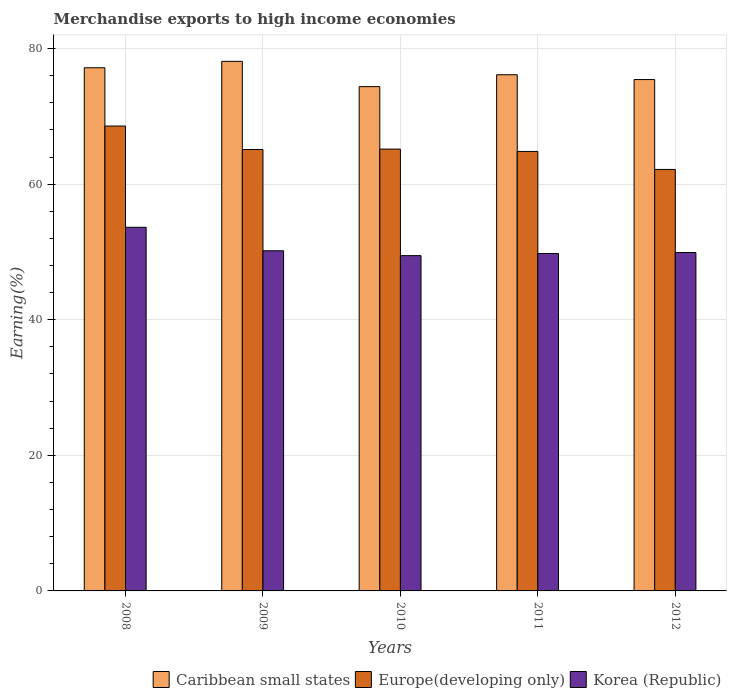How many different coloured bars are there?
Your response must be concise. 3. How many groups of bars are there?
Offer a terse response. 5. Are the number of bars on each tick of the X-axis equal?
Your answer should be compact. Yes. How many bars are there on the 3rd tick from the left?
Your response must be concise. 3. What is the percentage of amount earned from merchandise exports in Korea (Republic) in 2011?
Make the answer very short. 49.77. Across all years, what is the maximum percentage of amount earned from merchandise exports in Europe(developing only)?
Provide a succinct answer. 68.57. Across all years, what is the minimum percentage of amount earned from merchandise exports in Caribbean small states?
Your response must be concise. 74.38. In which year was the percentage of amount earned from merchandise exports in Europe(developing only) minimum?
Keep it short and to the point. 2012. What is the total percentage of amount earned from merchandise exports in Europe(developing only) in the graph?
Ensure brevity in your answer.  325.85. What is the difference between the percentage of amount earned from merchandise exports in Caribbean small states in 2009 and that in 2012?
Make the answer very short. 2.68. What is the difference between the percentage of amount earned from merchandise exports in Korea (Republic) in 2011 and the percentage of amount earned from merchandise exports in Caribbean small states in 2012?
Ensure brevity in your answer.  -25.66. What is the average percentage of amount earned from merchandise exports in Korea (Republic) per year?
Provide a short and direct response. 50.59. In the year 2012, what is the difference between the percentage of amount earned from merchandise exports in Caribbean small states and percentage of amount earned from merchandise exports in Europe(developing only)?
Provide a short and direct response. 13.26. What is the ratio of the percentage of amount earned from merchandise exports in Caribbean small states in 2009 to that in 2012?
Make the answer very short. 1.04. Is the difference between the percentage of amount earned from merchandise exports in Caribbean small states in 2010 and 2011 greater than the difference between the percentage of amount earned from merchandise exports in Europe(developing only) in 2010 and 2011?
Provide a short and direct response. No. What is the difference between the highest and the second highest percentage of amount earned from merchandise exports in Korea (Republic)?
Keep it short and to the point. 3.46. What is the difference between the highest and the lowest percentage of amount earned from merchandise exports in Korea (Republic)?
Your answer should be compact. 4.18. What does the 1st bar from the left in 2010 represents?
Your answer should be compact. Caribbean small states. How many bars are there?
Your answer should be very brief. 15. Are all the bars in the graph horizontal?
Your answer should be very brief. No. How many years are there in the graph?
Provide a succinct answer. 5. Does the graph contain any zero values?
Provide a short and direct response. No. Where does the legend appear in the graph?
Provide a short and direct response. Bottom right. How are the legend labels stacked?
Make the answer very short. Horizontal. What is the title of the graph?
Offer a very short reply. Merchandise exports to high income economies. Does "Ethiopia" appear as one of the legend labels in the graph?
Make the answer very short. No. What is the label or title of the X-axis?
Your response must be concise. Years. What is the label or title of the Y-axis?
Make the answer very short. Earning(%). What is the Earning(%) in Caribbean small states in 2008?
Keep it short and to the point. 77.17. What is the Earning(%) of Europe(developing only) in 2008?
Your response must be concise. 68.57. What is the Earning(%) of Korea (Republic) in 2008?
Keep it short and to the point. 53.64. What is the Earning(%) of Caribbean small states in 2009?
Offer a very short reply. 78.11. What is the Earning(%) of Europe(developing only) in 2009?
Provide a short and direct response. 65.11. What is the Earning(%) in Korea (Republic) in 2009?
Your response must be concise. 50.17. What is the Earning(%) of Caribbean small states in 2010?
Your response must be concise. 74.38. What is the Earning(%) of Europe(developing only) in 2010?
Ensure brevity in your answer.  65.17. What is the Earning(%) of Korea (Republic) in 2010?
Your response must be concise. 49.46. What is the Earning(%) of Caribbean small states in 2011?
Your answer should be very brief. 76.14. What is the Earning(%) in Europe(developing only) in 2011?
Offer a very short reply. 64.83. What is the Earning(%) of Korea (Republic) in 2011?
Make the answer very short. 49.77. What is the Earning(%) of Caribbean small states in 2012?
Your response must be concise. 75.43. What is the Earning(%) of Europe(developing only) in 2012?
Keep it short and to the point. 62.17. What is the Earning(%) of Korea (Republic) in 2012?
Make the answer very short. 49.92. Across all years, what is the maximum Earning(%) of Caribbean small states?
Your response must be concise. 78.11. Across all years, what is the maximum Earning(%) in Europe(developing only)?
Provide a short and direct response. 68.57. Across all years, what is the maximum Earning(%) of Korea (Republic)?
Offer a terse response. 53.64. Across all years, what is the minimum Earning(%) in Caribbean small states?
Offer a very short reply. 74.38. Across all years, what is the minimum Earning(%) of Europe(developing only)?
Your response must be concise. 62.17. Across all years, what is the minimum Earning(%) in Korea (Republic)?
Make the answer very short. 49.46. What is the total Earning(%) in Caribbean small states in the graph?
Ensure brevity in your answer.  381.23. What is the total Earning(%) of Europe(developing only) in the graph?
Your response must be concise. 325.85. What is the total Earning(%) in Korea (Republic) in the graph?
Your answer should be very brief. 252.95. What is the difference between the Earning(%) of Caribbean small states in 2008 and that in 2009?
Make the answer very short. -0.94. What is the difference between the Earning(%) in Europe(developing only) in 2008 and that in 2009?
Provide a succinct answer. 3.46. What is the difference between the Earning(%) of Korea (Republic) in 2008 and that in 2009?
Offer a terse response. 3.46. What is the difference between the Earning(%) in Caribbean small states in 2008 and that in 2010?
Ensure brevity in your answer.  2.78. What is the difference between the Earning(%) of Europe(developing only) in 2008 and that in 2010?
Keep it short and to the point. 3.4. What is the difference between the Earning(%) of Korea (Republic) in 2008 and that in 2010?
Your answer should be compact. 4.18. What is the difference between the Earning(%) of Europe(developing only) in 2008 and that in 2011?
Your answer should be very brief. 3.75. What is the difference between the Earning(%) in Korea (Republic) in 2008 and that in 2011?
Offer a terse response. 3.87. What is the difference between the Earning(%) in Caribbean small states in 2008 and that in 2012?
Ensure brevity in your answer.  1.74. What is the difference between the Earning(%) in Europe(developing only) in 2008 and that in 2012?
Offer a very short reply. 6.4. What is the difference between the Earning(%) in Korea (Republic) in 2008 and that in 2012?
Keep it short and to the point. 3.72. What is the difference between the Earning(%) of Caribbean small states in 2009 and that in 2010?
Provide a short and direct response. 3.73. What is the difference between the Earning(%) of Europe(developing only) in 2009 and that in 2010?
Offer a very short reply. -0.06. What is the difference between the Earning(%) of Korea (Republic) in 2009 and that in 2010?
Your answer should be compact. 0.72. What is the difference between the Earning(%) in Caribbean small states in 2009 and that in 2011?
Provide a short and direct response. 1.98. What is the difference between the Earning(%) in Europe(developing only) in 2009 and that in 2011?
Provide a succinct answer. 0.28. What is the difference between the Earning(%) in Korea (Republic) in 2009 and that in 2011?
Keep it short and to the point. 0.4. What is the difference between the Earning(%) of Caribbean small states in 2009 and that in 2012?
Your answer should be very brief. 2.68. What is the difference between the Earning(%) in Europe(developing only) in 2009 and that in 2012?
Give a very brief answer. 2.94. What is the difference between the Earning(%) in Korea (Republic) in 2009 and that in 2012?
Your response must be concise. 0.26. What is the difference between the Earning(%) of Caribbean small states in 2010 and that in 2011?
Provide a short and direct response. -1.75. What is the difference between the Earning(%) in Europe(developing only) in 2010 and that in 2011?
Your answer should be very brief. 0.34. What is the difference between the Earning(%) in Korea (Republic) in 2010 and that in 2011?
Provide a short and direct response. -0.31. What is the difference between the Earning(%) in Caribbean small states in 2010 and that in 2012?
Offer a terse response. -1.05. What is the difference between the Earning(%) of Europe(developing only) in 2010 and that in 2012?
Your answer should be very brief. 3. What is the difference between the Earning(%) in Korea (Republic) in 2010 and that in 2012?
Your answer should be very brief. -0.46. What is the difference between the Earning(%) of Caribbean small states in 2011 and that in 2012?
Make the answer very short. 0.71. What is the difference between the Earning(%) of Europe(developing only) in 2011 and that in 2012?
Offer a very short reply. 2.66. What is the difference between the Earning(%) in Korea (Republic) in 2011 and that in 2012?
Your answer should be compact. -0.15. What is the difference between the Earning(%) in Caribbean small states in 2008 and the Earning(%) in Europe(developing only) in 2009?
Offer a very short reply. 12.06. What is the difference between the Earning(%) in Caribbean small states in 2008 and the Earning(%) in Korea (Republic) in 2009?
Provide a succinct answer. 26.99. What is the difference between the Earning(%) in Europe(developing only) in 2008 and the Earning(%) in Korea (Republic) in 2009?
Provide a succinct answer. 18.4. What is the difference between the Earning(%) in Caribbean small states in 2008 and the Earning(%) in Europe(developing only) in 2010?
Offer a very short reply. 12. What is the difference between the Earning(%) in Caribbean small states in 2008 and the Earning(%) in Korea (Republic) in 2010?
Your answer should be compact. 27.71. What is the difference between the Earning(%) in Europe(developing only) in 2008 and the Earning(%) in Korea (Republic) in 2010?
Offer a very short reply. 19.12. What is the difference between the Earning(%) in Caribbean small states in 2008 and the Earning(%) in Europe(developing only) in 2011?
Provide a short and direct response. 12.34. What is the difference between the Earning(%) in Caribbean small states in 2008 and the Earning(%) in Korea (Republic) in 2011?
Your answer should be very brief. 27.4. What is the difference between the Earning(%) of Europe(developing only) in 2008 and the Earning(%) of Korea (Republic) in 2011?
Your answer should be very brief. 18.8. What is the difference between the Earning(%) in Caribbean small states in 2008 and the Earning(%) in Europe(developing only) in 2012?
Provide a succinct answer. 15. What is the difference between the Earning(%) of Caribbean small states in 2008 and the Earning(%) of Korea (Republic) in 2012?
Offer a very short reply. 27.25. What is the difference between the Earning(%) in Europe(developing only) in 2008 and the Earning(%) in Korea (Republic) in 2012?
Provide a succinct answer. 18.66. What is the difference between the Earning(%) of Caribbean small states in 2009 and the Earning(%) of Europe(developing only) in 2010?
Your response must be concise. 12.94. What is the difference between the Earning(%) in Caribbean small states in 2009 and the Earning(%) in Korea (Republic) in 2010?
Your answer should be very brief. 28.66. What is the difference between the Earning(%) of Europe(developing only) in 2009 and the Earning(%) of Korea (Republic) in 2010?
Give a very brief answer. 15.66. What is the difference between the Earning(%) of Caribbean small states in 2009 and the Earning(%) of Europe(developing only) in 2011?
Your response must be concise. 13.29. What is the difference between the Earning(%) in Caribbean small states in 2009 and the Earning(%) in Korea (Republic) in 2011?
Your response must be concise. 28.34. What is the difference between the Earning(%) of Europe(developing only) in 2009 and the Earning(%) of Korea (Republic) in 2011?
Offer a terse response. 15.34. What is the difference between the Earning(%) of Caribbean small states in 2009 and the Earning(%) of Europe(developing only) in 2012?
Your answer should be compact. 15.94. What is the difference between the Earning(%) in Caribbean small states in 2009 and the Earning(%) in Korea (Republic) in 2012?
Offer a terse response. 28.2. What is the difference between the Earning(%) in Europe(developing only) in 2009 and the Earning(%) in Korea (Republic) in 2012?
Provide a succinct answer. 15.19. What is the difference between the Earning(%) of Caribbean small states in 2010 and the Earning(%) of Europe(developing only) in 2011?
Provide a short and direct response. 9.56. What is the difference between the Earning(%) of Caribbean small states in 2010 and the Earning(%) of Korea (Republic) in 2011?
Your answer should be compact. 24.61. What is the difference between the Earning(%) in Europe(developing only) in 2010 and the Earning(%) in Korea (Republic) in 2011?
Keep it short and to the point. 15.4. What is the difference between the Earning(%) of Caribbean small states in 2010 and the Earning(%) of Europe(developing only) in 2012?
Make the answer very short. 12.21. What is the difference between the Earning(%) of Caribbean small states in 2010 and the Earning(%) of Korea (Republic) in 2012?
Provide a short and direct response. 24.47. What is the difference between the Earning(%) of Europe(developing only) in 2010 and the Earning(%) of Korea (Republic) in 2012?
Offer a terse response. 15.25. What is the difference between the Earning(%) of Caribbean small states in 2011 and the Earning(%) of Europe(developing only) in 2012?
Make the answer very short. 13.96. What is the difference between the Earning(%) of Caribbean small states in 2011 and the Earning(%) of Korea (Republic) in 2012?
Your answer should be compact. 26.22. What is the difference between the Earning(%) in Europe(developing only) in 2011 and the Earning(%) in Korea (Republic) in 2012?
Give a very brief answer. 14.91. What is the average Earning(%) of Caribbean small states per year?
Give a very brief answer. 76.25. What is the average Earning(%) in Europe(developing only) per year?
Provide a succinct answer. 65.17. What is the average Earning(%) in Korea (Republic) per year?
Give a very brief answer. 50.59. In the year 2008, what is the difference between the Earning(%) in Caribbean small states and Earning(%) in Europe(developing only)?
Provide a succinct answer. 8.6. In the year 2008, what is the difference between the Earning(%) of Caribbean small states and Earning(%) of Korea (Republic)?
Provide a short and direct response. 23.53. In the year 2008, what is the difference between the Earning(%) in Europe(developing only) and Earning(%) in Korea (Republic)?
Give a very brief answer. 14.94. In the year 2009, what is the difference between the Earning(%) of Caribbean small states and Earning(%) of Europe(developing only)?
Provide a succinct answer. 13. In the year 2009, what is the difference between the Earning(%) in Caribbean small states and Earning(%) in Korea (Republic)?
Offer a terse response. 27.94. In the year 2009, what is the difference between the Earning(%) in Europe(developing only) and Earning(%) in Korea (Republic)?
Give a very brief answer. 14.94. In the year 2010, what is the difference between the Earning(%) of Caribbean small states and Earning(%) of Europe(developing only)?
Ensure brevity in your answer.  9.22. In the year 2010, what is the difference between the Earning(%) in Caribbean small states and Earning(%) in Korea (Republic)?
Offer a very short reply. 24.93. In the year 2010, what is the difference between the Earning(%) in Europe(developing only) and Earning(%) in Korea (Republic)?
Your response must be concise. 15.71. In the year 2011, what is the difference between the Earning(%) of Caribbean small states and Earning(%) of Europe(developing only)?
Offer a very short reply. 11.31. In the year 2011, what is the difference between the Earning(%) of Caribbean small states and Earning(%) of Korea (Republic)?
Make the answer very short. 26.36. In the year 2011, what is the difference between the Earning(%) in Europe(developing only) and Earning(%) in Korea (Republic)?
Keep it short and to the point. 15.06. In the year 2012, what is the difference between the Earning(%) of Caribbean small states and Earning(%) of Europe(developing only)?
Offer a very short reply. 13.26. In the year 2012, what is the difference between the Earning(%) in Caribbean small states and Earning(%) in Korea (Republic)?
Your response must be concise. 25.51. In the year 2012, what is the difference between the Earning(%) of Europe(developing only) and Earning(%) of Korea (Republic)?
Ensure brevity in your answer.  12.26. What is the ratio of the Earning(%) of Caribbean small states in 2008 to that in 2009?
Your answer should be compact. 0.99. What is the ratio of the Earning(%) of Europe(developing only) in 2008 to that in 2009?
Your response must be concise. 1.05. What is the ratio of the Earning(%) of Korea (Republic) in 2008 to that in 2009?
Provide a succinct answer. 1.07. What is the ratio of the Earning(%) of Caribbean small states in 2008 to that in 2010?
Offer a terse response. 1.04. What is the ratio of the Earning(%) in Europe(developing only) in 2008 to that in 2010?
Your answer should be compact. 1.05. What is the ratio of the Earning(%) in Korea (Republic) in 2008 to that in 2010?
Keep it short and to the point. 1.08. What is the ratio of the Earning(%) in Caribbean small states in 2008 to that in 2011?
Keep it short and to the point. 1.01. What is the ratio of the Earning(%) in Europe(developing only) in 2008 to that in 2011?
Keep it short and to the point. 1.06. What is the ratio of the Earning(%) of Korea (Republic) in 2008 to that in 2011?
Ensure brevity in your answer.  1.08. What is the ratio of the Earning(%) of Caribbean small states in 2008 to that in 2012?
Your answer should be compact. 1.02. What is the ratio of the Earning(%) in Europe(developing only) in 2008 to that in 2012?
Provide a succinct answer. 1.1. What is the ratio of the Earning(%) of Korea (Republic) in 2008 to that in 2012?
Offer a very short reply. 1.07. What is the ratio of the Earning(%) in Caribbean small states in 2009 to that in 2010?
Offer a terse response. 1.05. What is the ratio of the Earning(%) of Korea (Republic) in 2009 to that in 2010?
Your response must be concise. 1.01. What is the ratio of the Earning(%) of Caribbean small states in 2009 to that in 2011?
Provide a short and direct response. 1.03. What is the ratio of the Earning(%) of Korea (Republic) in 2009 to that in 2011?
Offer a terse response. 1.01. What is the ratio of the Earning(%) of Caribbean small states in 2009 to that in 2012?
Offer a terse response. 1.04. What is the ratio of the Earning(%) of Europe(developing only) in 2009 to that in 2012?
Offer a very short reply. 1.05. What is the ratio of the Earning(%) of Korea (Republic) in 2009 to that in 2012?
Provide a succinct answer. 1.01. What is the ratio of the Earning(%) in Korea (Republic) in 2010 to that in 2011?
Your answer should be compact. 0.99. What is the ratio of the Earning(%) of Caribbean small states in 2010 to that in 2012?
Offer a very short reply. 0.99. What is the ratio of the Earning(%) in Europe(developing only) in 2010 to that in 2012?
Your answer should be very brief. 1.05. What is the ratio of the Earning(%) of Caribbean small states in 2011 to that in 2012?
Keep it short and to the point. 1.01. What is the ratio of the Earning(%) in Europe(developing only) in 2011 to that in 2012?
Ensure brevity in your answer.  1.04. What is the difference between the highest and the second highest Earning(%) in Caribbean small states?
Give a very brief answer. 0.94. What is the difference between the highest and the second highest Earning(%) in Europe(developing only)?
Offer a terse response. 3.4. What is the difference between the highest and the second highest Earning(%) in Korea (Republic)?
Offer a very short reply. 3.46. What is the difference between the highest and the lowest Earning(%) of Caribbean small states?
Make the answer very short. 3.73. What is the difference between the highest and the lowest Earning(%) of Europe(developing only)?
Your answer should be compact. 6.4. What is the difference between the highest and the lowest Earning(%) of Korea (Republic)?
Make the answer very short. 4.18. 